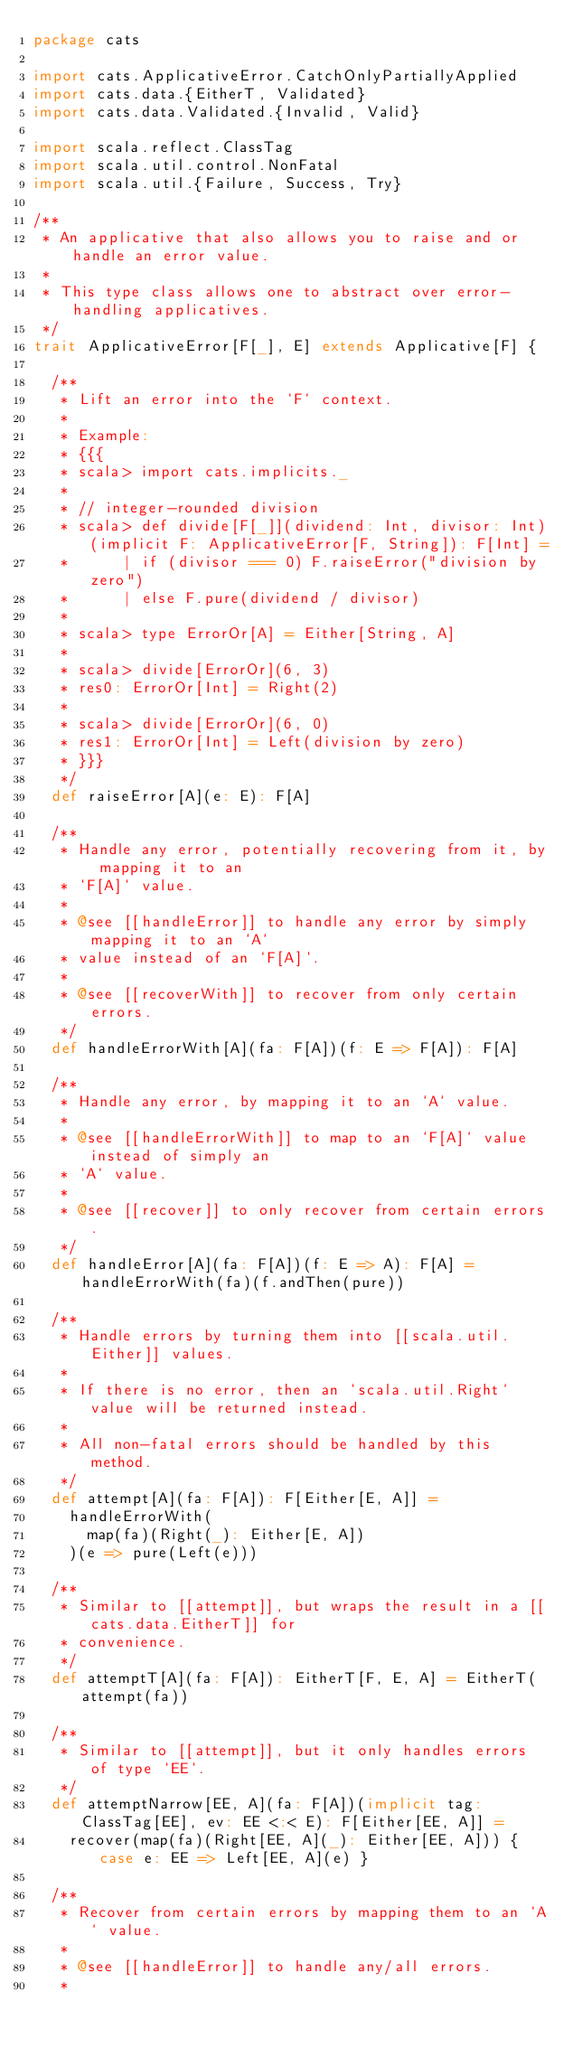Convert code to text. <code><loc_0><loc_0><loc_500><loc_500><_Scala_>package cats

import cats.ApplicativeError.CatchOnlyPartiallyApplied
import cats.data.{EitherT, Validated}
import cats.data.Validated.{Invalid, Valid}

import scala.reflect.ClassTag
import scala.util.control.NonFatal
import scala.util.{Failure, Success, Try}

/**
 * An applicative that also allows you to raise and or handle an error value.
 *
 * This type class allows one to abstract over error-handling applicatives.
 */
trait ApplicativeError[F[_], E] extends Applicative[F] {

  /**
   * Lift an error into the `F` context.
   *
   * Example:
   * {{{
   * scala> import cats.implicits._
   *
   * // integer-rounded division
   * scala> def divide[F[_]](dividend: Int, divisor: Int)(implicit F: ApplicativeError[F, String]): F[Int] =
   *      | if (divisor === 0) F.raiseError("division by zero")
   *      | else F.pure(dividend / divisor)
   *
   * scala> type ErrorOr[A] = Either[String, A]
   *
   * scala> divide[ErrorOr](6, 3)
   * res0: ErrorOr[Int] = Right(2)
   *
   * scala> divide[ErrorOr](6, 0)
   * res1: ErrorOr[Int] = Left(division by zero)
   * }}}
   */
  def raiseError[A](e: E): F[A]

  /**
   * Handle any error, potentially recovering from it, by mapping it to an
   * `F[A]` value.
   *
   * @see [[handleError]] to handle any error by simply mapping it to an `A`
   * value instead of an `F[A]`.
   *
   * @see [[recoverWith]] to recover from only certain errors.
   */
  def handleErrorWith[A](fa: F[A])(f: E => F[A]): F[A]

  /**
   * Handle any error, by mapping it to an `A` value.
   *
   * @see [[handleErrorWith]] to map to an `F[A]` value instead of simply an
   * `A` value.
   *
   * @see [[recover]] to only recover from certain errors.
   */
  def handleError[A](fa: F[A])(f: E => A): F[A] = handleErrorWith(fa)(f.andThen(pure))

  /**
   * Handle errors by turning them into [[scala.util.Either]] values.
   *
   * If there is no error, then an `scala.util.Right` value will be returned instead.
   *
   * All non-fatal errors should be handled by this method.
   */
  def attempt[A](fa: F[A]): F[Either[E, A]] =
    handleErrorWith(
      map(fa)(Right(_): Either[E, A])
    )(e => pure(Left(e)))

  /**
   * Similar to [[attempt]], but wraps the result in a [[cats.data.EitherT]] for
   * convenience.
   */
  def attemptT[A](fa: F[A]): EitherT[F, E, A] = EitherT(attempt(fa))

  /**
   * Similar to [[attempt]], but it only handles errors of type `EE`.
   */
  def attemptNarrow[EE, A](fa: F[A])(implicit tag: ClassTag[EE], ev: EE <:< E): F[Either[EE, A]] =
    recover(map(fa)(Right[EE, A](_): Either[EE, A])) { case e: EE => Left[EE, A](e) }

  /**
   * Recover from certain errors by mapping them to an `A` value.
   *
   * @see [[handleError]] to handle any/all errors.
   *</code> 